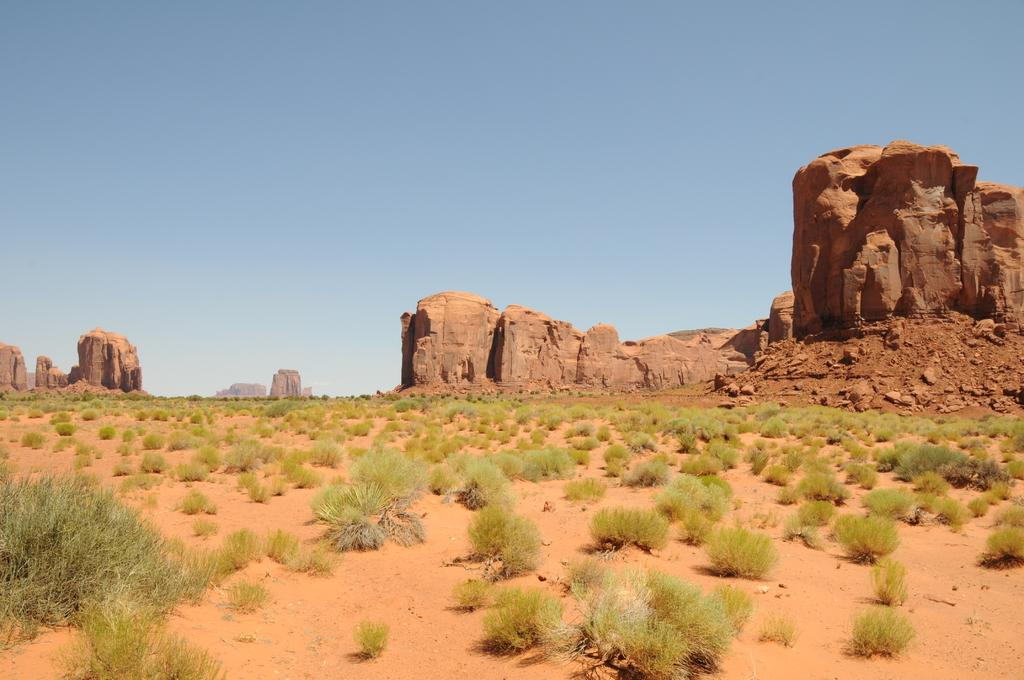What type of area is depicted in the image? There is an open ground in the image. What can be seen on the open ground? There are multiple plants on the open ground. What other elements are visible in the background of the image? There are rocks and the sky visible in the background of the image. What type of coal is being used to write in the notebook in the image? There is no coal or notebook present in the image. What reward is being given to the person in the image? There is no person or reward present in the image. 